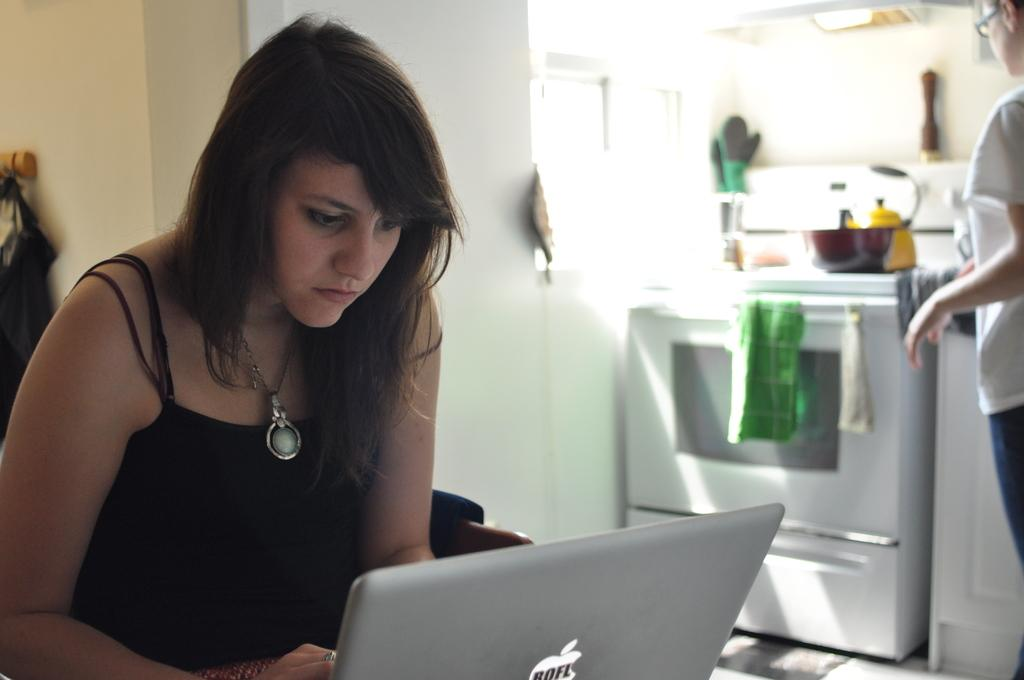<image>
Summarize the visual content of the image. A dark haired woman looks at a laptop that has an apple on the front with the letters ROFL in the apple. 